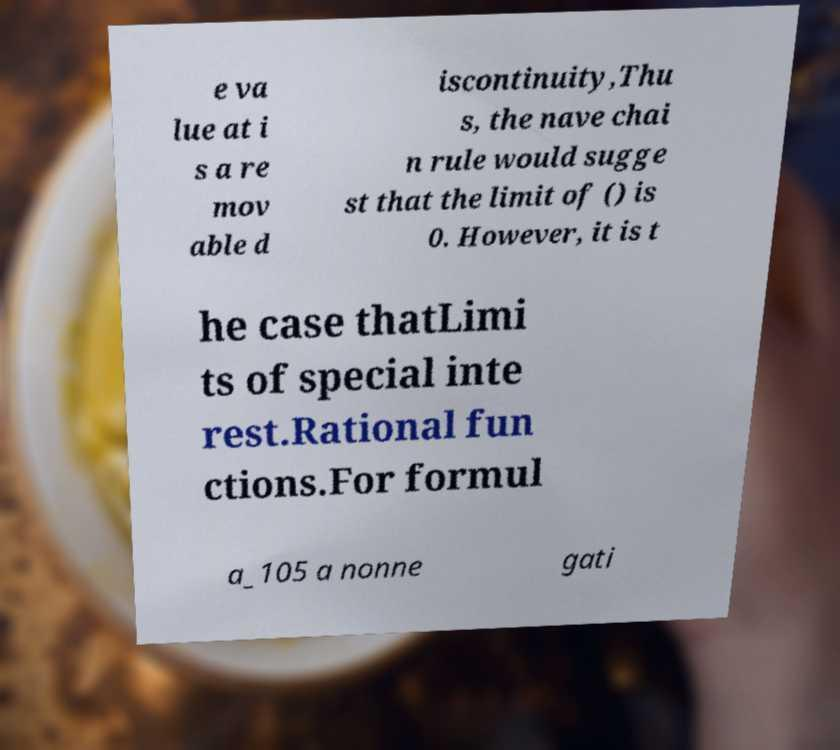Can you read and provide the text displayed in the image?This photo seems to have some interesting text. Can you extract and type it out for me? e va lue at i s a re mov able d iscontinuity,Thu s, the nave chai n rule would sugge st that the limit of () is 0. However, it is t he case thatLimi ts of special inte rest.Rational fun ctions.For formul a_105 a nonne gati 